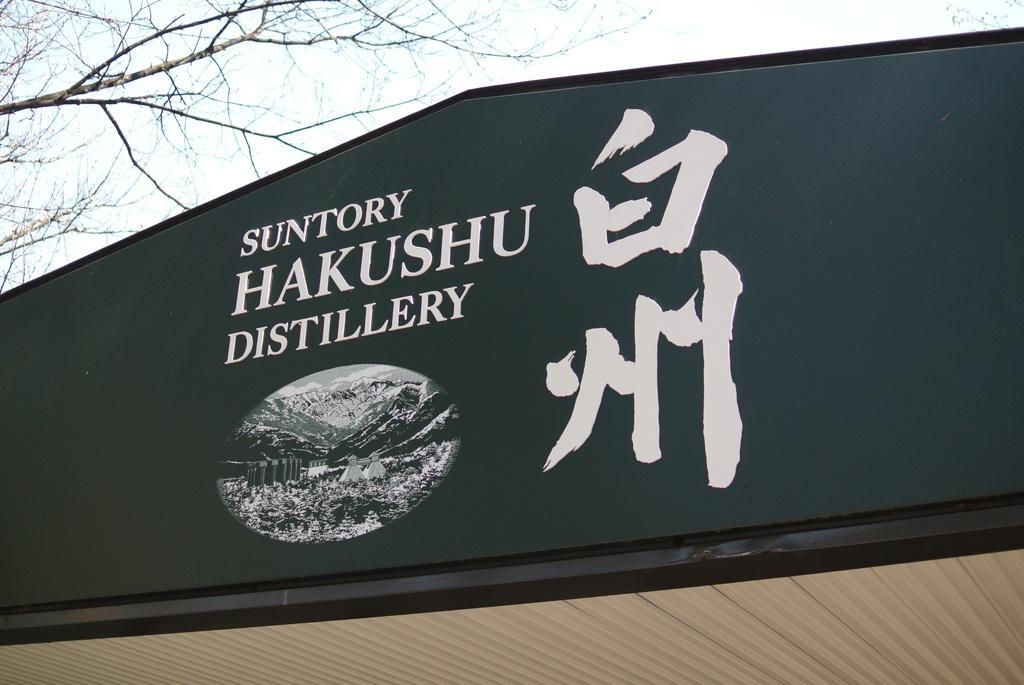Could you give a brief overview of what you see in this image? In this image we can see a name board, sky and tree. 